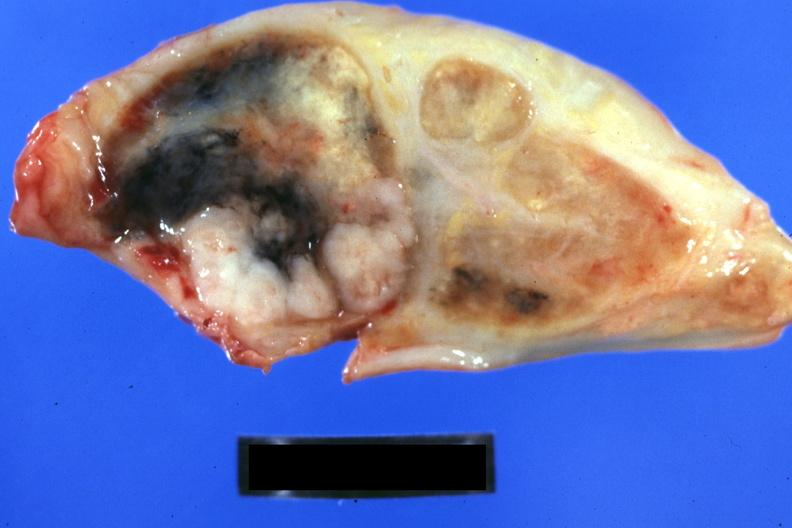s metastatic carcinoma lung present?
Answer the question using a single word or phrase. Yes 